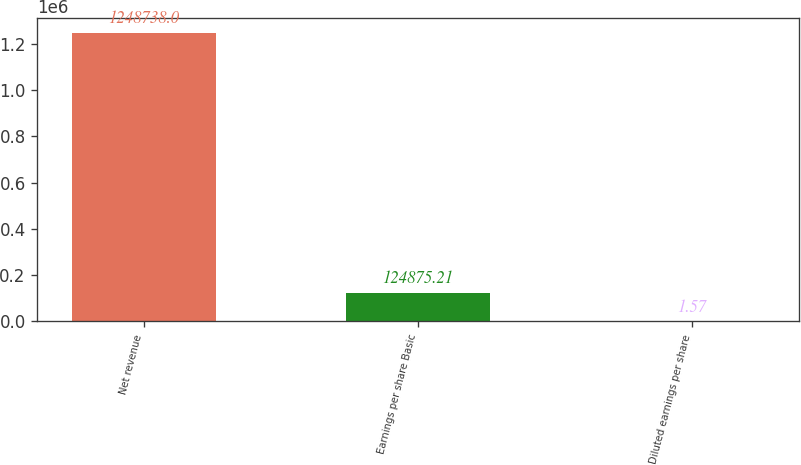Convert chart to OTSL. <chart><loc_0><loc_0><loc_500><loc_500><bar_chart><fcel>Net revenue<fcel>Earnings per share Basic<fcel>Diluted earnings per share<nl><fcel>1.24874e+06<fcel>124875<fcel>1.57<nl></chart> 